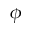Convert formula to latex. <formula><loc_0><loc_0><loc_500><loc_500>\phi</formula> 